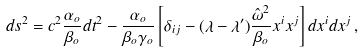Convert formula to latex. <formula><loc_0><loc_0><loc_500><loc_500>d s ^ { 2 } = c ^ { 2 } \frac { \alpha _ { o } } { \beta _ { o } } d t ^ { 2 } - \frac { \alpha _ { o } } { \beta _ { o } \gamma _ { o } } \left [ \delta _ { i j } - ( \lambda - \lambda ^ { \prime } ) \frac { \hat { \omega } ^ { 2 } } { \beta _ { o } } x ^ { i } x ^ { j } \right ] d x ^ { i } d x ^ { j } \, ,</formula> 